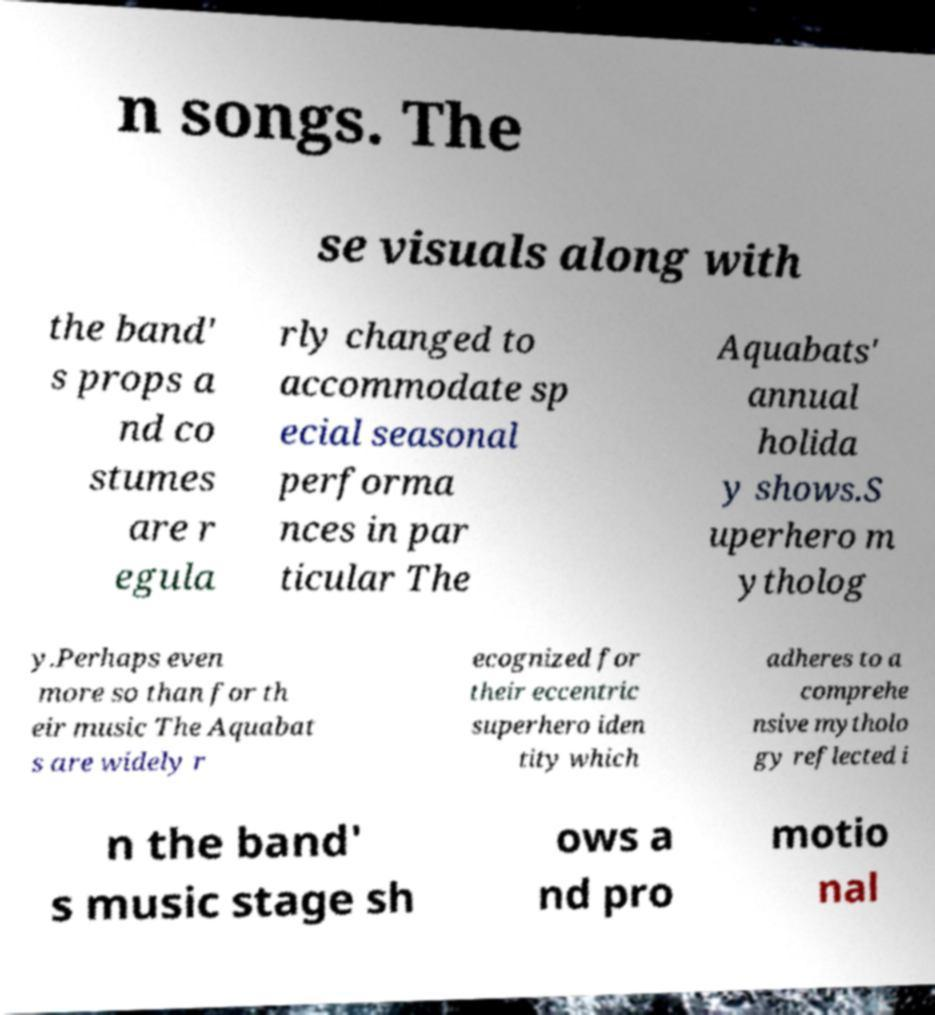Can you read and provide the text displayed in the image?This photo seems to have some interesting text. Can you extract and type it out for me? n songs. The se visuals along with the band' s props a nd co stumes are r egula rly changed to accommodate sp ecial seasonal performa nces in par ticular The Aquabats' annual holida y shows.S uperhero m ytholog y.Perhaps even more so than for th eir music The Aquabat s are widely r ecognized for their eccentric superhero iden tity which adheres to a comprehe nsive mytholo gy reflected i n the band' s music stage sh ows a nd pro motio nal 